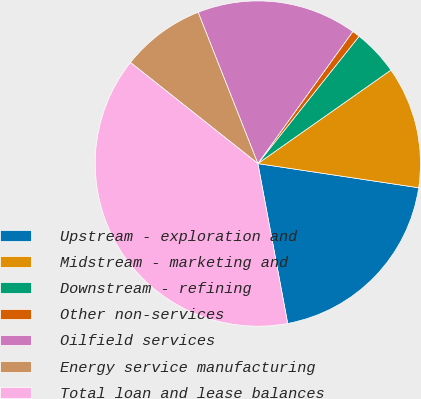Convert chart. <chart><loc_0><loc_0><loc_500><loc_500><pie_chart><fcel>Upstream - exploration and<fcel>Midstream - marketing and<fcel>Downstream - refining<fcel>Other non-services<fcel>Oilfield services<fcel>Energy service manufacturing<fcel>Total loan and lease balances<nl><fcel>19.69%<fcel>12.12%<fcel>4.56%<fcel>0.77%<fcel>15.91%<fcel>8.34%<fcel>38.61%<nl></chart> 